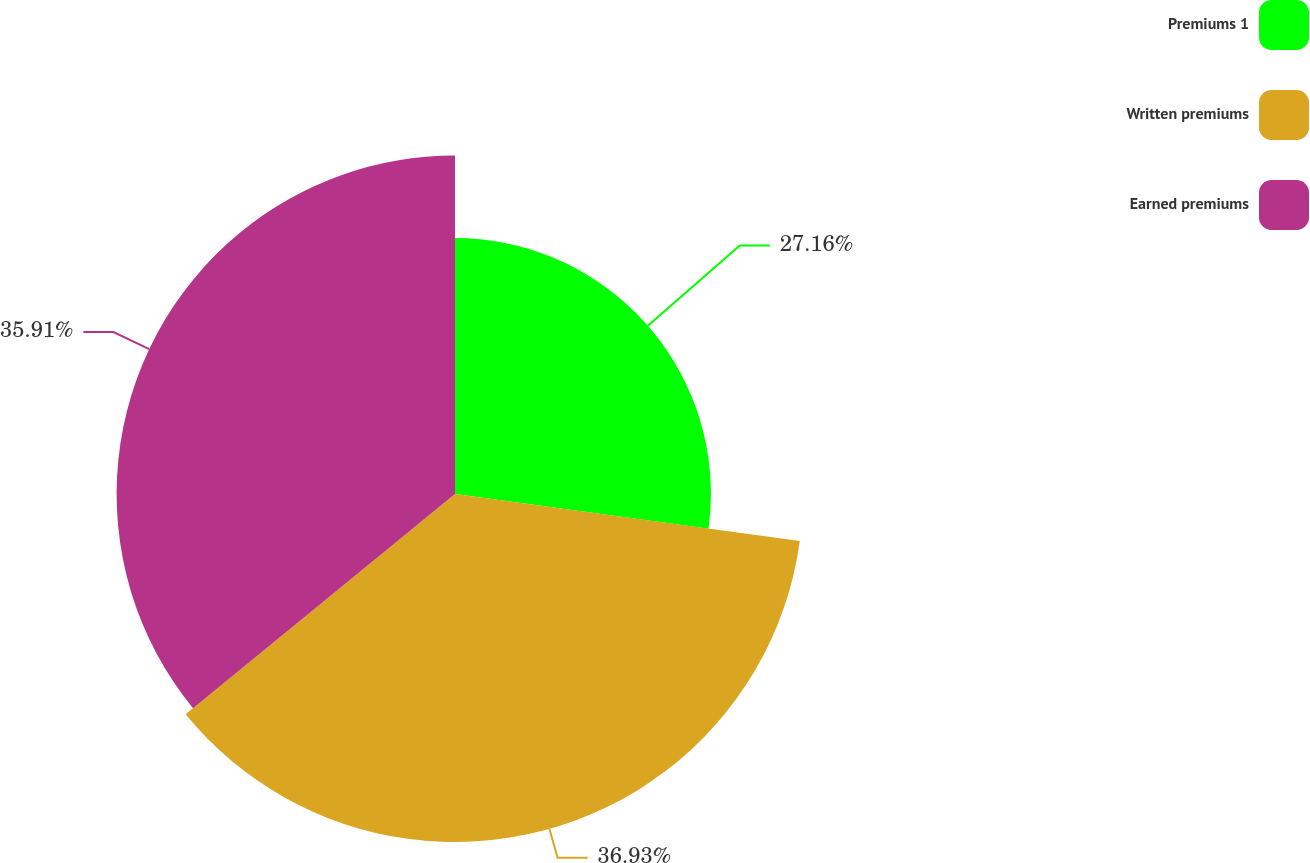Convert chart. <chart><loc_0><loc_0><loc_500><loc_500><pie_chart><fcel>Premiums 1<fcel>Written premiums<fcel>Earned premiums<nl><fcel>27.16%<fcel>36.93%<fcel>35.91%<nl></chart> 